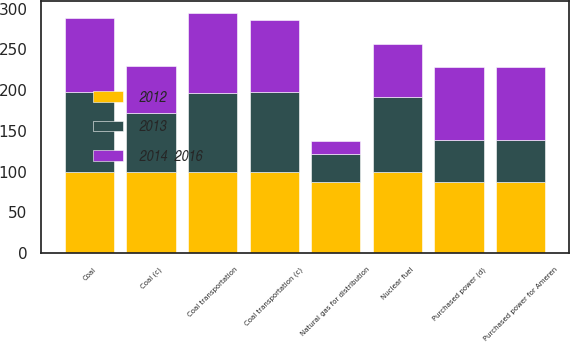Convert chart. <chart><loc_0><loc_0><loc_500><loc_500><stacked_bar_chart><ecel><fcel>Coal (c)<fcel>Coal transportation (c)<fcel>Nuclear fuel<fcel>Natural gas for distribution<fcel>Purchased power for Ameren<fcel>Coal<fcel>Coal transportation<fcel>Purchased power (d)<nl><fcel>2012<fcel>99<fcel>100<fcel>100<fcel>87<fcel>87<fcel>100<fcel>100<fcel>87<nl><fcel>2013<fcel>73<fcel>98<fcel>92<fcel>35<fcel>52<fcel>98<fcel>97<fcel>52<nl><fcel>2014  2016<fcel>57<fcel>88<fcel>64<fcel>16<fcel>89<fcel>90<fcel>97<fcel>89<nl></chart> 